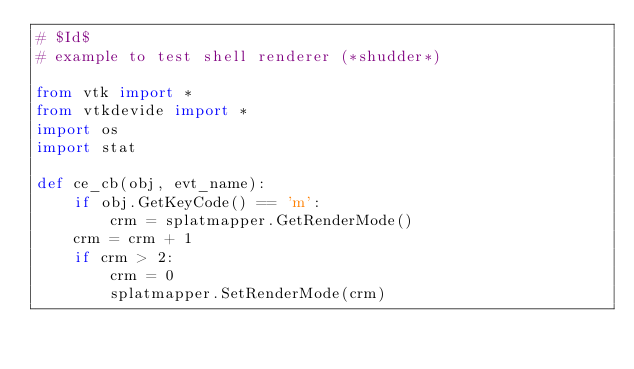Convert code to text. <code><loc_0><loc_0><loc_500><loc_500><_Python_># $Id$
# example to test shell renderer (*shudder*)

from vtk import *
from vtkdevide import *
import os
import stat

def ce_cb(obj, evt_name):
    if obj.GetKeyCode() == 'm':
        crm = splatmapper.GetRenderMode()
	crm = crm + 1
	if crm > 2:
	    crm = 0
        splatmapper.SetRenderMode(crm)</code> 